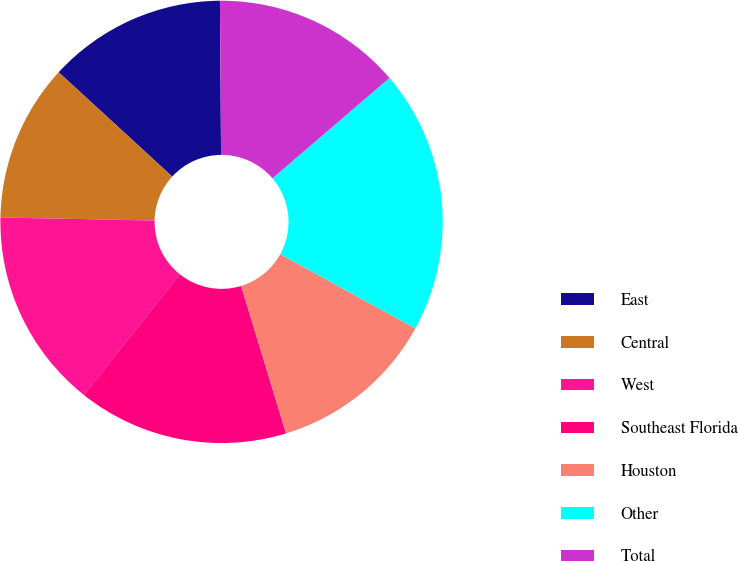<chart> <loc_0><loc_0><loc_500><loc_500><pie_chart><fcel>East<fcel>Central<fcel>West<fcel>Southeast Florida<fcel>Houston<fcel>Other<fcel>Total<nl><fcel>13.06%<fcel>11.51%<fcel>14.62%<fcel>15.4%<fcel>12.29%<fcel>19.28%<fcel>13.84%<nl></chart> 